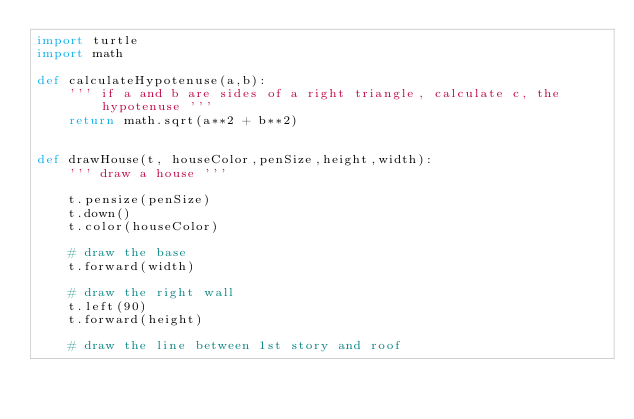<code> <loc_0><loc_0><loc_500><loc_500><_Python_>import turtle
import math    

def calculateHypotenuse(a,b):
    ''' if a and b are sides of a right triangle, calculate c, the hypotenuse '''
    return math.sqrt(a**2 + b**2)


def drawHouse(t, houseColor,penSize,height,width):
    ''' draw a house '''

    t.pensize(penSize)
    t.down()
    t.color(houseColor)

    # draw the base
    t.forward(width)

    # draw the right wall
    t.left(90)
    t.forward(height)

    # draw the line between 1st story and roof</code> 